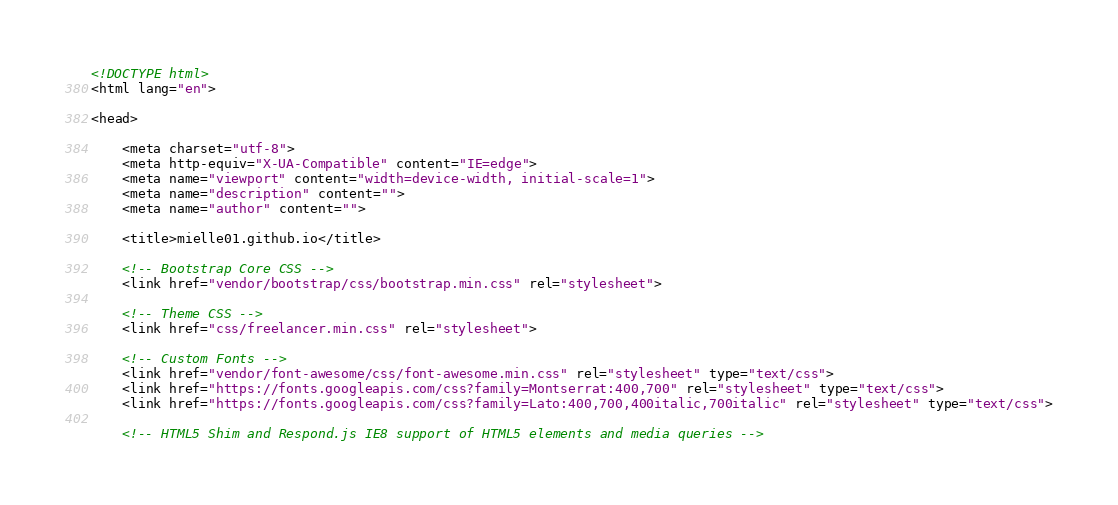Convert code to text. <code><loc_0><loc_0><loc_500><loc_500><_HTML_><!DOCTYPE html>
<html lang="en">

<head>

    <meta charset="utf-8">
    <meta http-equiv="X-UA-Compatible" content="IE=edge">
    <meta name="viewport" content="width=device-width, initial-scale=1">
    <meta name="description" content="">
    <meta name="author" content="">

    <title>mielle01.github.io</title>

    <!-- Bootstrap Core CSS -->
    <link href="vendor/bootstrap/css/bootstrap.min.css" rel="stylesheet">

    <!-- Theme CSS -->
    <link href="css/freelancer.min.css" rel="stylesheet">

    <!-- Custom Fonts -->
    <link href="vendor/font-awesome/css/font-awesome.min.css" rel="stylesheet" type="text/css">
    <link href="https://fonts.googleapis.com/css?family=Montserrat:400,700" rel="stylesheet" type="text/css">
    <link href="https://fonts.googleapis.com/css?family=Lato:400,700,400italic,700italic" rel="stylesheet" type="text/css">

    <!-- HTML5 Shim and Respond.js IE8 support of HTML5 elements and media queries --></code> 